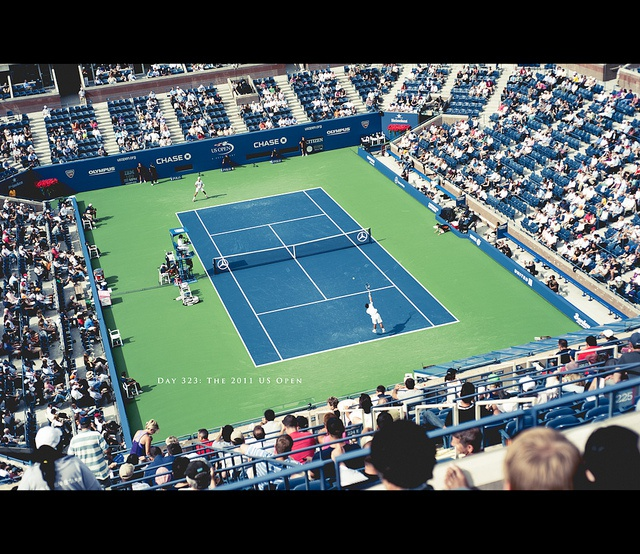Describe the objects in this image and their specific colors. I can see people in black, ivory, navy, and gray tones, people in black, lightgray, darkgray, and gray tones, people in black, ivory, darkgray, and blue tones, people in black, brown, salmon, and maroon tones, and people in black, gray, navy, and darkgray tones in this image. 